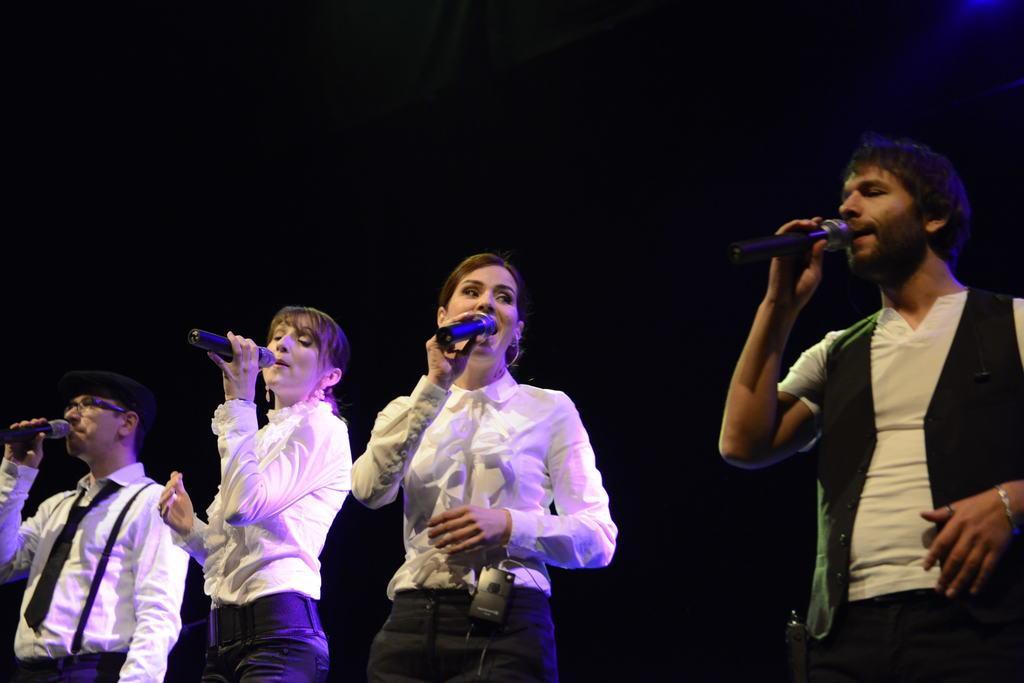How would you summarize this image in a sentence or two? In this image, There are some people standing and they are holding some microphones which are in black color and they are singing in the microphones. 